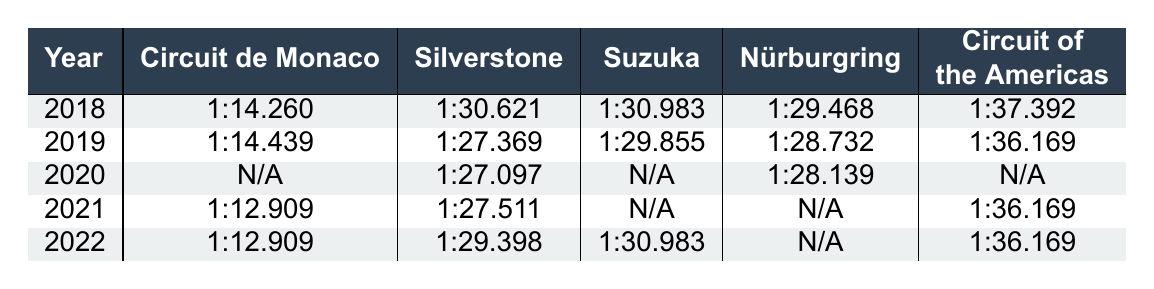What was the lap time for the Circuit de Monaco in 2021? The table shows that in 2021, the lap time for the Circuit de Monaco was 1:12.909.
Answer: 1:12.909 Which circuit had the slowest lap time in 2019? In 2019, the lap time for Circuit of the Americas was 1:36.169, which is the slowest among all circuits listed that year.
Answer: Circuit of the Americas What is the lap time difference between the fastest and slowest circuits in 2022? The fastest lap time in 2022 was 1:12.909 (Circuit de Monaco) and the slowest was 1:36.169 (Circuit of the Americas). The difference is calculated as 1:36.169 - 1:12.909 = 23.260 seconds.
Answer: 23.260 seconds Was there a lap time recorded for Suzuka in 2020? The table indicates that the lap time for Suzuka in 2020 is marked as N/A, meaning there was no time recorded.
Answer: No What was the average lap time for Silverstone over the five years listed? The lap times for Silverstone are 1:30.621, 1:27.369, 1:27.097, 1:27.511, and 1:29.398. To find the average, first convert these times to seconds: 90.621, 87.369, 87.097, 87.511, 89.398. The total is 432.996 seconds divided by 5 gives an average lap time of approximately 1:26.599 (rounded to 3 decimal places).
Answer: 1:26.599 In which year did the Circuit de Monaco record the fastest lap time according to the table? The fastest lap time for Circuit de Monaco was in 2021, recorded as 1:12.909.
Answer: 2021 How many circuits had recorded lap times in 2020? The table shows that only Silverstone and Nürburgring had recorded lap times in 2020, as the others are marked N/A.
Answer: 2 circuits In which year did the lap time for the Circuit of the Americas remain consistent? The lap time for Circuit of the Americas remained consistent at 1:36.169 in both 2021 and 2022, indicating no change over those two years.
Answer: 2021 and 2022 What is the trend in lap times for Circuit de Monaco from 2018 to 2022? From 2018 to 2022, the lap times went from 1:14.260 in 2018 to 1:12.909 in both 2021 and 2022, showing an improvement over those years, while the time for 2019 (1:14.439) was slightly slower than 2018.
Answer: Improvement overall What missing data points exist in the table for specific years? The table indicates missing data points (N/A) for Circuit de Monaco and Suzuka in 2020, as well as Suzuka and Nürburgring in 2021, and Nürburgring in 2022.
Answer: 4 missing data points 